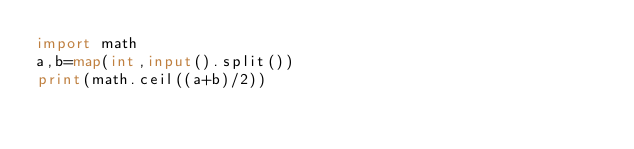<code> <loc_0><loc_0><loc_500><loc_500><_Python_>import math
a,b=map(int,input().split())
print(math.ceil((a+b)/2))
</code> 